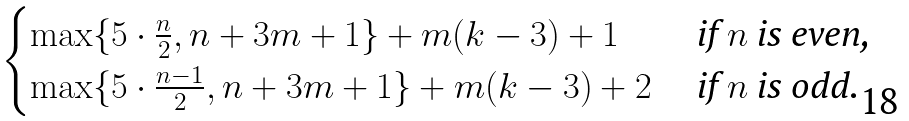Convert formula to latex. <formula><loc_0><loc_0><loc_500><loc_500>\begin{cases} \max \{ 5 \cdot \frac { n } { 2 } , n + 3 m + 1 \} + m ( k - 3 ) + 1 & \text { if $n$ is even,} \\ \max \{ 5 \cdot \frac { n - 1 } { 2 } , n + 3 m + 1 \} + m ( k - 3 ) + 2 & \text { if $n$ is odd.} \end{cases}</formula> 